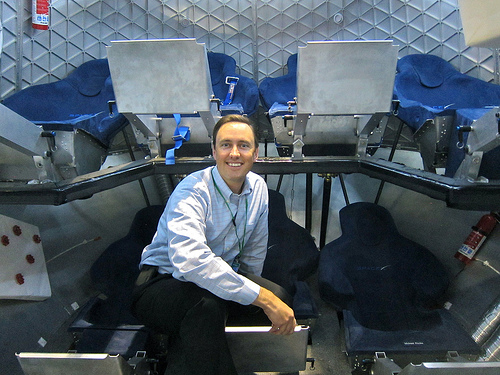<image>
Can you confirm if the man is in front of the fire extinguisher? No. The man is not in front of the fire extinguisher. The spatial positioning shows a different relationship between these objects. 